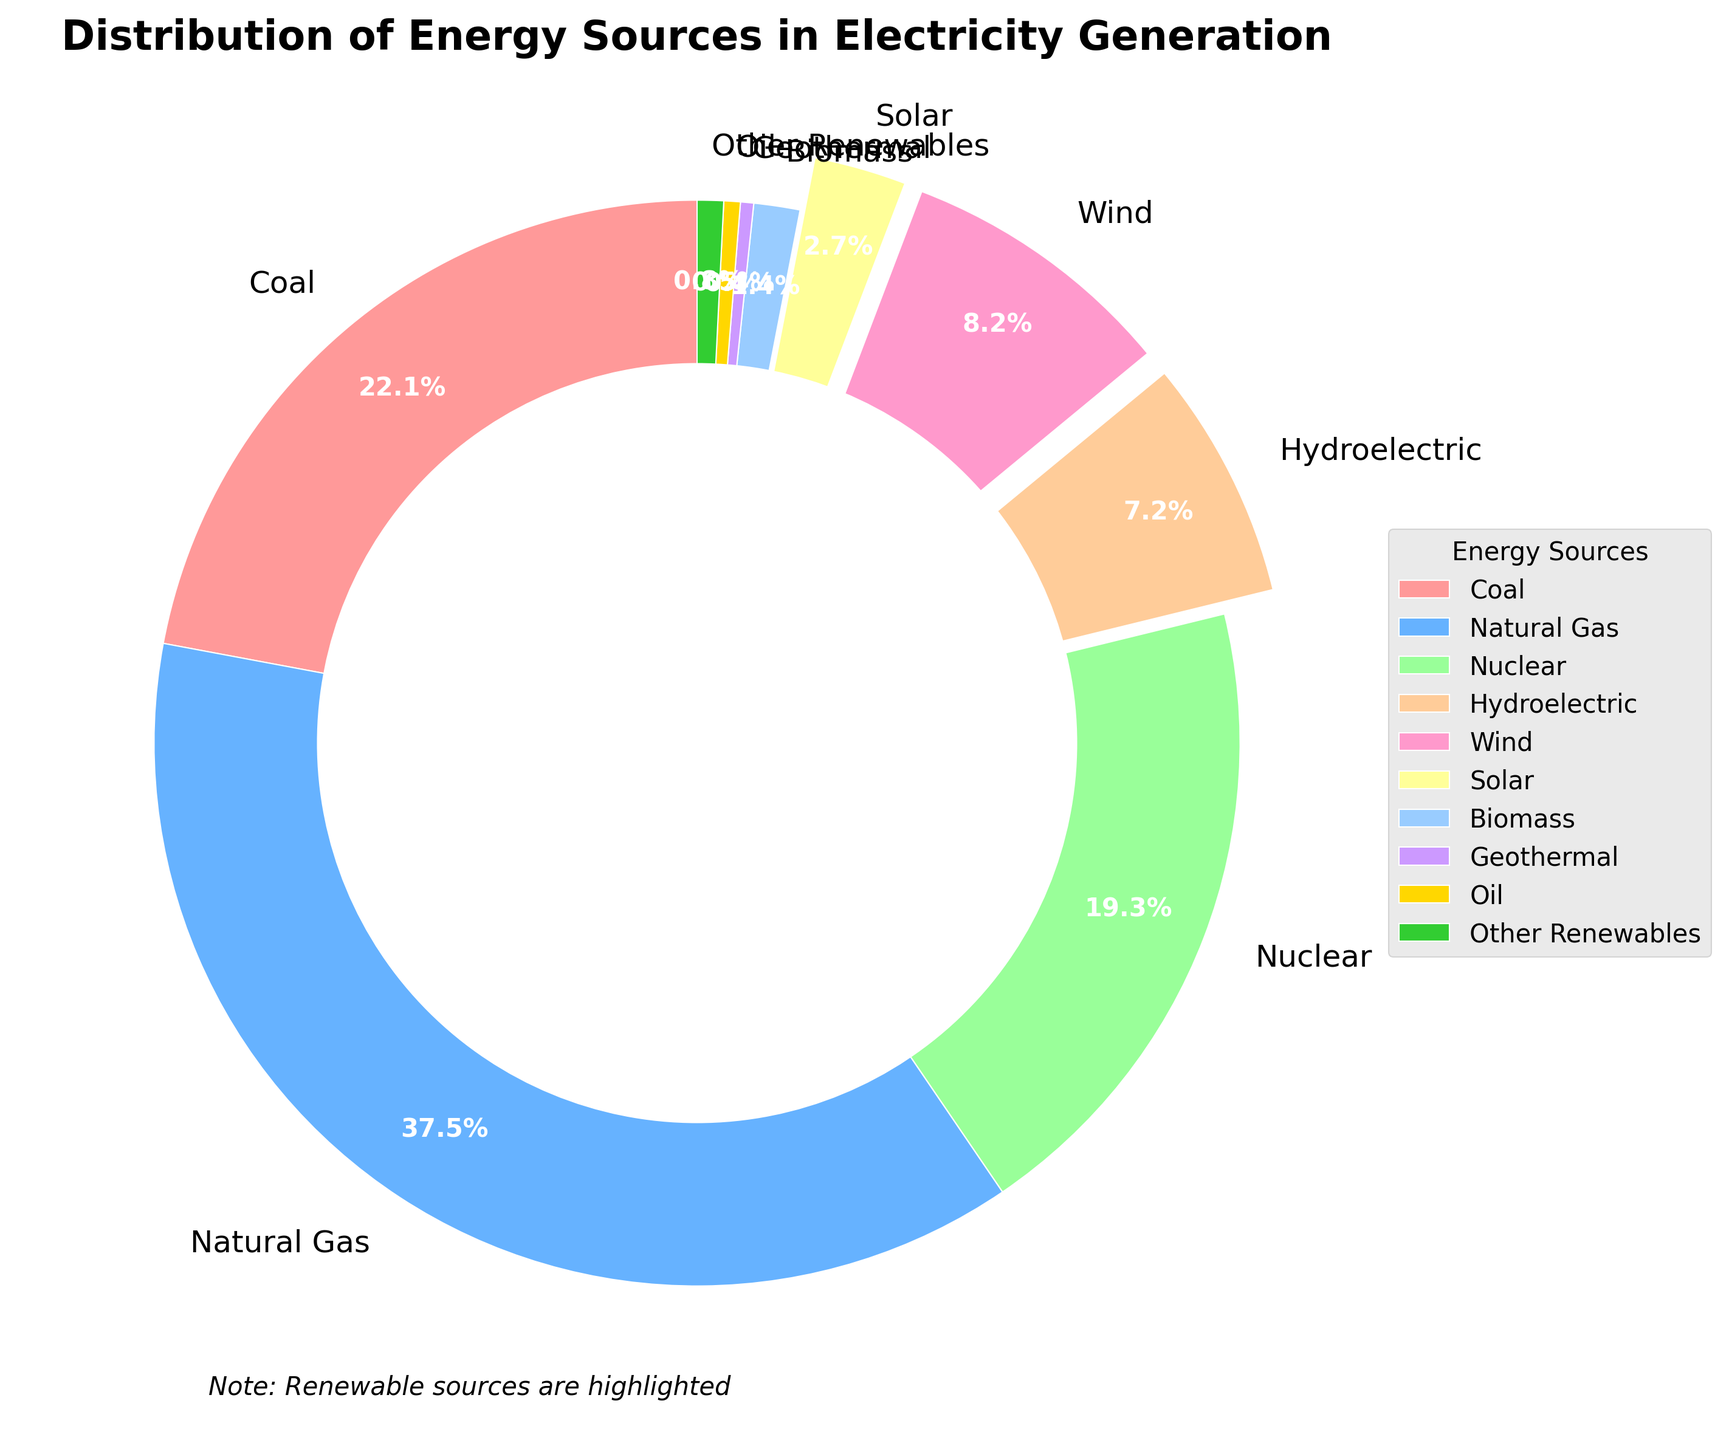Which energy source contributes the most to electricity generation? By visually examining the largest sector in the pie chart, we see that Natural Gas occupies the largest portion.
Answer: Natural Gas What percentage of electricity is generated by renewable sources combined? Add the percentages of all renewable sources: Hydroelectric (7.3), Wind (8.4), Solar (2.8), Biomass (1.4), Geothermal (0.4), and Other Renewables (0.8). The total is 7.3 + 8.4 + 2.8 + 1.4 + 0.4 + 0.8 = 21.1%
Answer: 21.1% Which three renewable sources contribute the least to electricity generation? Identify the smallest sectors among the renewable sources. Geothermal (0.4), Other Renewables (0.8), and Biomass (1.4) are visually the smallest on the pie chart.
Answer: Geothermal, Other Renewables, Biomass How much more electricity is generated by Nuclear compared to Hydroelectric? Subtract the percentage of Hydroelectric (7.3%) from Nuclear (19.7%) to find the difference. 19.7 - 7.3 = 12.4
Answer: 12.4% Are non-renewable sources the major contributors to electricity generation? Add the percentages of all non-renewable sources: Coal (22.5), Natural Gas (38.2), Nuclear (19.7), Oil (0.5). The total is 22.5 + 38.2 + 19.7 + 0.5 = 80.9%, which constitutes the majority.
Answer: Yes By how much does Natural Gas exceed the next highest energy source in terms of contribution? The next highest energy source after Natural Gas (38.2%) is Coal (22.5%). Subtract Coal from Natural Gas to find the excess percentage, 38.2 - 22.5 = 15.7.
Answer: 15.7% Which renewable source is highlighted by an explode effect? Observe the sectors with separate or exploded sections, which are Wind, Solar, and Hydroelectric. These are highlighted for emphasis on renewable sources.
Answer: Wind, Solar, Hydroelectric How does the combined percentage of Wind and Solar compare to that of Nuclear energy? Add Wind (8.4) and Solar (2.8), then compare this to Nuclear (19.7). The combined percentage is 8.4 + 2.8 = 11.2, less than Nuclear.
Answer: Less than Nuclear 